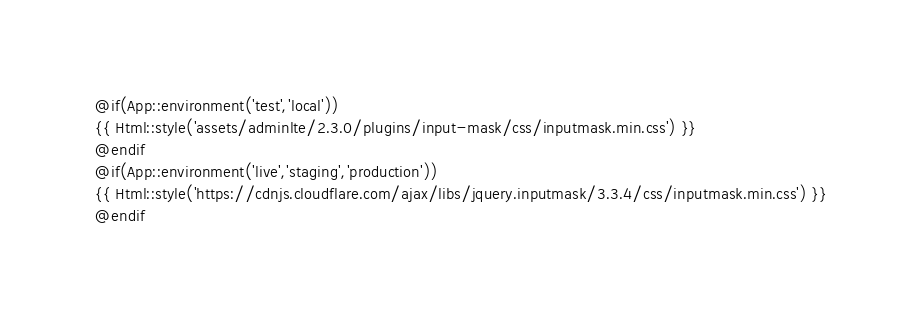<code> <loc_0><loc_0><loc_500><loc_500><_PHP_>@if(App::environment('test','local'))
{{ Html::style('assets/adminlte/2.3.0/plugins/input-mask/css/inputmask.min.css') }}
@endif
@if(App::environment('live','staging','production'))
{{ Html::style('https://cdnjs.cloudflare.com/ajax/libs/jquery.inputmask/3.3.4/css/inputmask.min.css') }}
@endif
</code> 